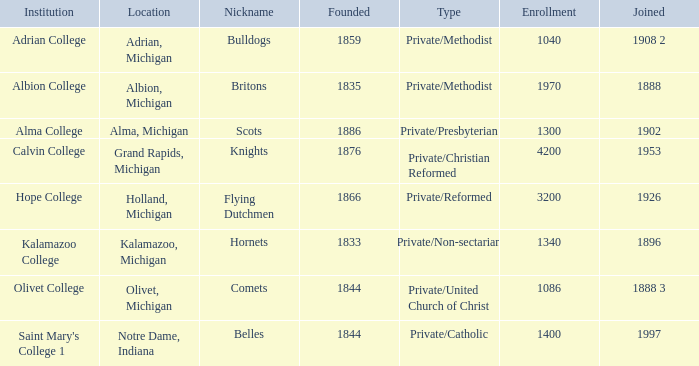Under belles, which is the most possible created? 1844.0. 